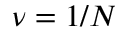Convert formula to latex. <formula><loc_0><loc_0><loc_500><loc_500>\nu = 1 / N</formula> 